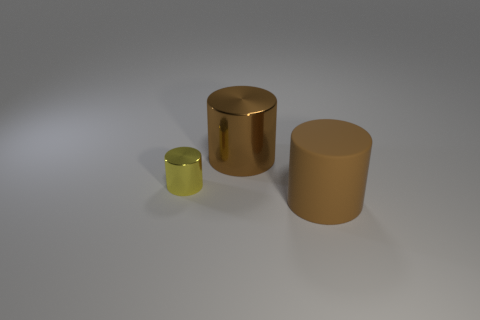Add 3 large blue metal spheres. How many objects exist? 6 Subtract 0 brown blocks. How many objects are left? 3 Subtract all large brown rubber things. Subtract all tiny yellow things. How many objects are left? 1 Add 1 large brown cylinders. How many large brown cylinders are left? 3 Add 3 yellow metal things. How many yellow metal things exist? 4 